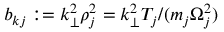Convert formula to latex. <formula><loc_0><loc_0><loc_500><loc_500>b _ { k j } \colon = k _ { \perp } ^ { 2 } \rho _ { j } ^ { 2 } = k _ { \perp } ^ { 2 } T _ { j } / ( m _ { j } \Omega _ { j } ^ { 2 } )</formula> 